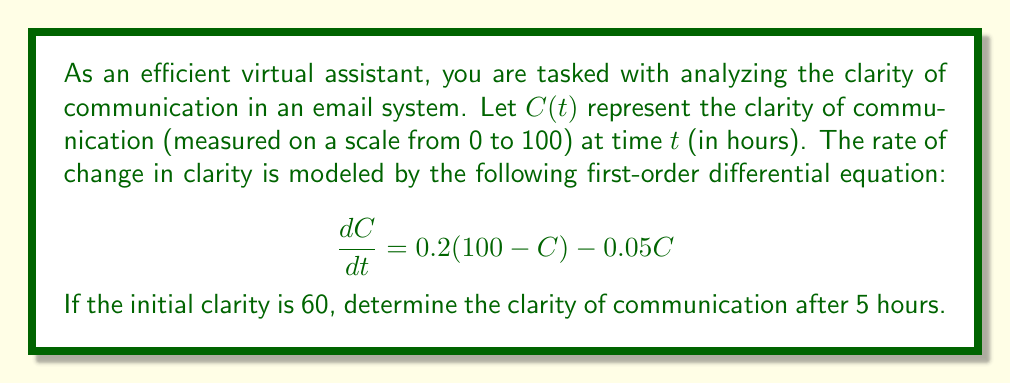Show me your answer to this math problem. To solve this problem, we'll follow these steps:

1) First, we need to solve the given differential equation:
   $$\frac{dC}{dt} = 0.2(100 - C) - 0.05C$$

2) Simplify the right-hand side:
   $$\frac{dC}{dt} = 20 - 0.2C - 0.05C = 20 - 0.25C$$

3) This is a linear first-order differential equation of the form:
   $$\frac{dC}{dt} + 0.25C = 20$$

4) The general solution for this type of equation is:
   $$C(t) = Ce^{-0.25t} + 80$$
   where $C$ is a constant to be determined.

5) Use the initial condition $C(0) = 60$ to find $C$:
   $$60 = C + 80$$
   $$C = -20$$

6) Therefore, the particular solution is:
   $$C(t) = 80 - 20e^{-0.25t}$$

7) To find the clarity after 5 hours, substitute $t = 5$:
   $$C(5) = 80 - 20e^{-0.25(5)}$$
   $$C(5) = 80 - 20e^{-1.25}$$
   $$C(5) \approx 74.28$$
Answer: The clarity of communication after 5 hours is approximately 74.28 on a scale from 0 to 100. 